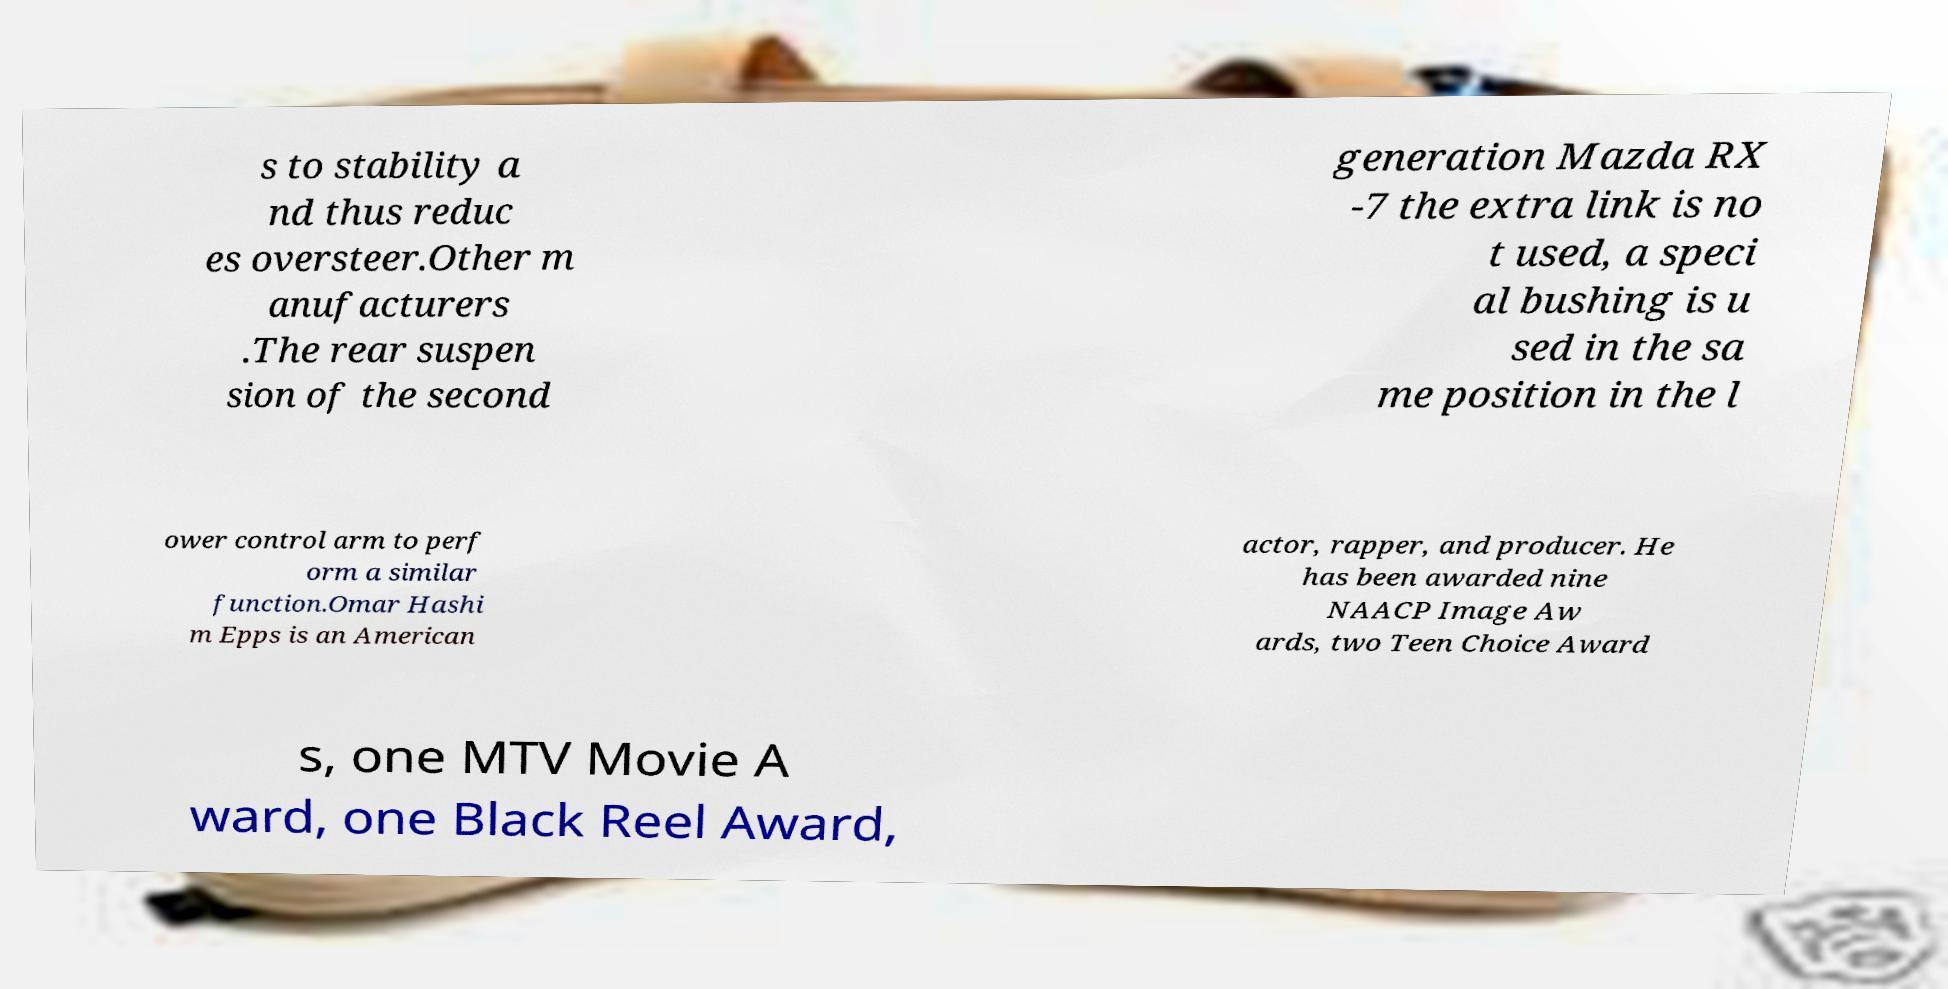What messages or text are displayed in this image? I need them in a readable, typed format. s to stability a nd thus reduc es oversteer.Other m anufacturers .The rear suspen sion of the second generation Mazda RX -7 the extra link is no t used, a speci al bushing is u sed in the sa me position in the l ower control arm to perf orm a similar function.Omar Hashi m Epps is an American actor, rapper, and producer. He has been awarded nine NAACP Image Aw ards, two Teen Choice Award s, one MTV Movie A ward, one Black Reel Award, 